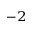<formula> <loc_0><loc_0><loc_500><loc_500>^ { - 2 }</formula> 